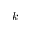<formula> <loc_0><loc_0><loc_500><loc_500>k</formula> 